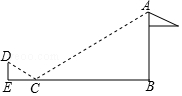Could you explain why triangles CDE and CAB are considered similar in this scenario? Absolutely, triangles CDE and CAB are deemed similar due to AA (Angle-Angle) similarity criterion. This indicates that two triangles are similar if they have two corresponding angles that are equal. In our diagram, the angle formed by DEC (or CDE) and the angle formed by ABC are both right angles, which means they're equal. The angle at point C, shared by both triangles, is equal due to the reflection properties of light. With two pairs of corresponding angles being equal, the triangles are indeed similar. This similarity means the ratios of their corresponding sides are proportional, a critical factor that enables us to calculate the unknown height of the flagpole.  Is there another method we could use to determine the height of the flagpole besides geometric optics or similar triangles? Certainly! Another approach is to use trigonometry. If we know the distance from Xiaofan to the mirror (CE) and the angle of elevation from Xiaofan's eyes to the top of the pole (angle DEC), we could calculate the height of the flagpole by tangent function, which relates the angles of a right triangle to the ratio of the side opposite to the angle and the side adjacent to it. However, without knowing the angle of elevation, the method used in the original solution with similar triangles and proportional reasoning is the most effective and straightforward here. 